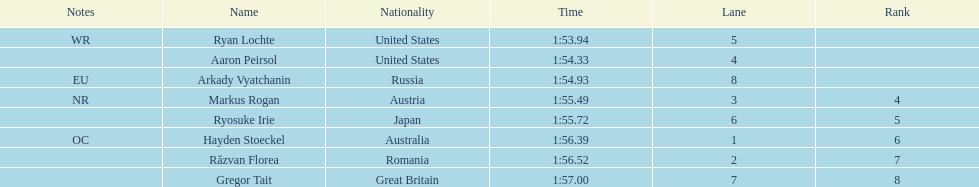Which country had the most medals in the competition? United States. 